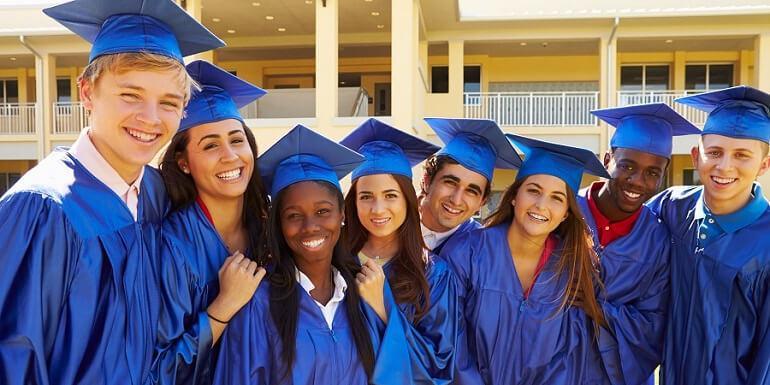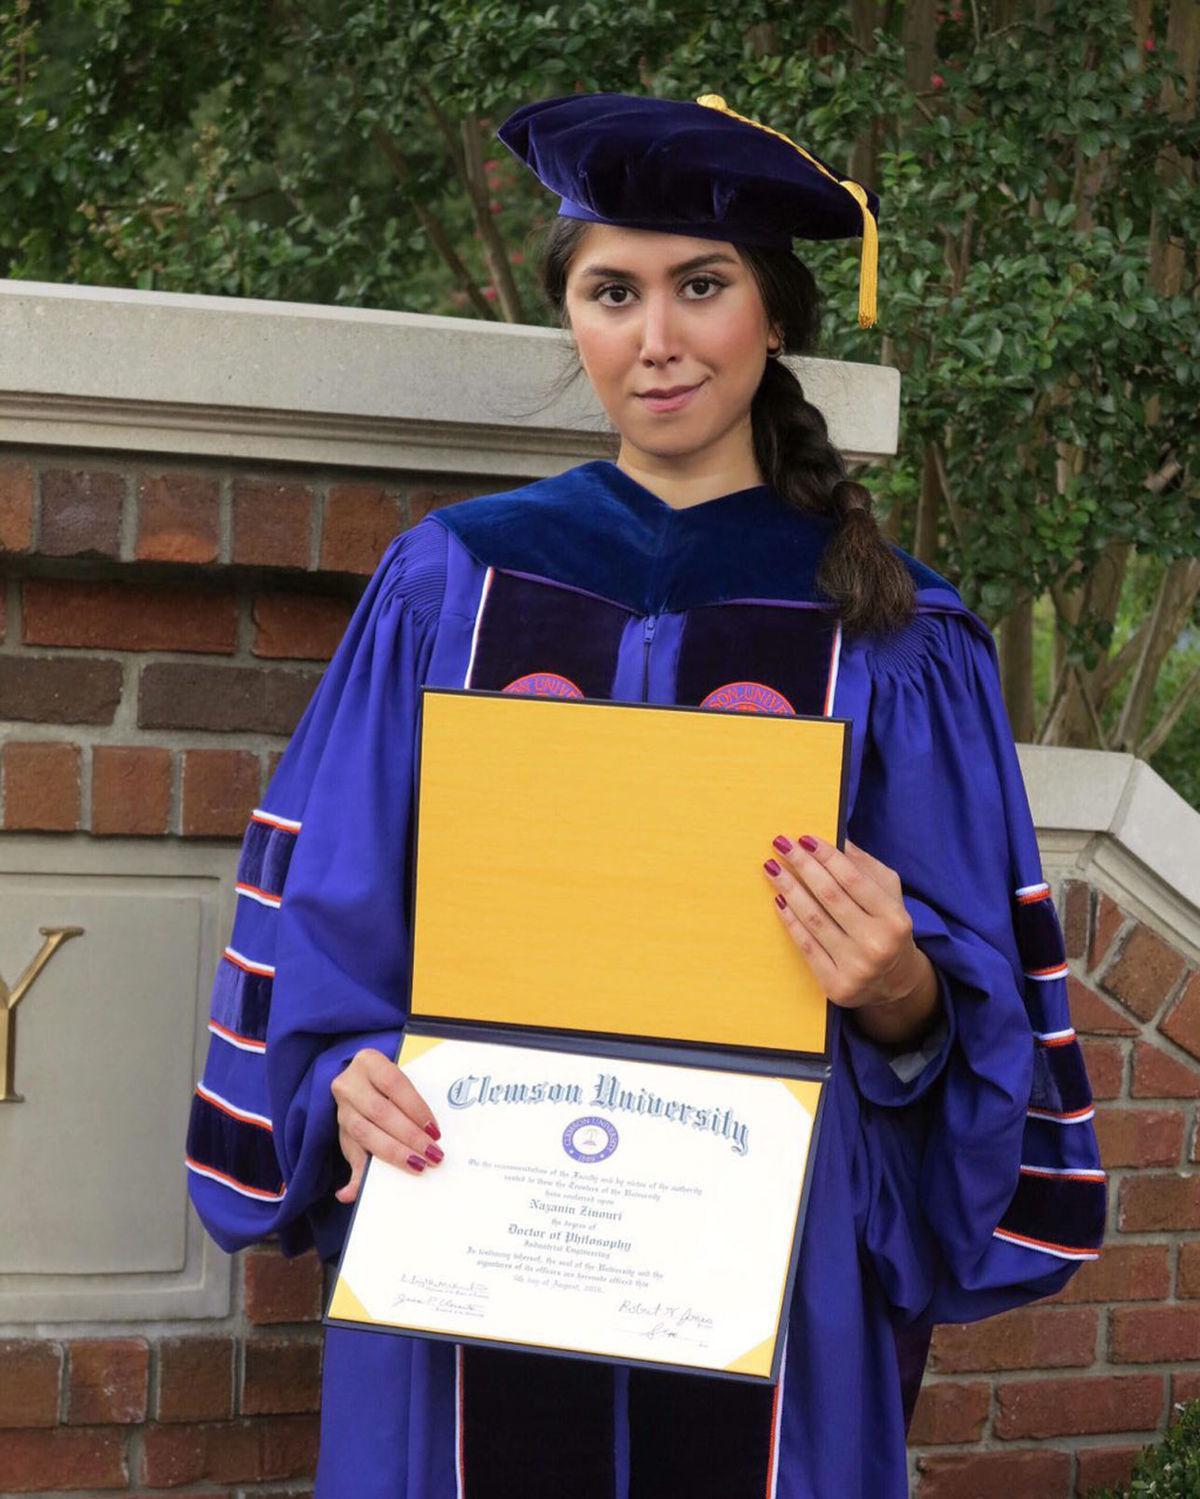The first image is the image on the left, the second image is the image on the right. Assess this claim about the two images: "One image includes at least two female graduates wearing black caps and robes with orange sashes, and the other image shows only one person in a graduate robe in the foreground.". Correct or not? Answer yes or no. No. The first image is the image on the left, the second image is the image on the right. Analyze the images presented: Is the assertion "There are at least two women wearing orange sashes." valid? Answer yes or no. No. 